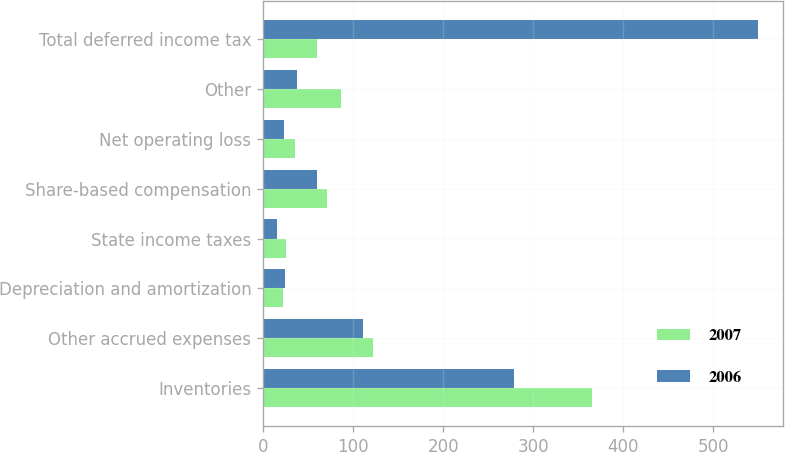Convert chart to OTSL. <chart><loc_0><loc_0><loc_500><loc_500><stacked_bar_chart><ecel><fcel>Inventories<fcel>Other accrued expenses<fcel>Depreciation and amortization<fcel>State income taxes<fcel>Share-based compensation<fcel>Net operating loss<fcel>Other<fcel>Total deferred income tax<nl><fcel>2007<fcel>365.1<fcel>121.8<fcel>21.7<fcel>25.4<fcel>70.5<fcel>35.4<fcel>86.9<fcel>60.1<nl><fcel>2006<fcel>278.6<fcel>110.7<fcel>24.5<fcel>15<fcel>60.1<fcel>23.3<fcel>38<fcel>550.2<nl></chart> 